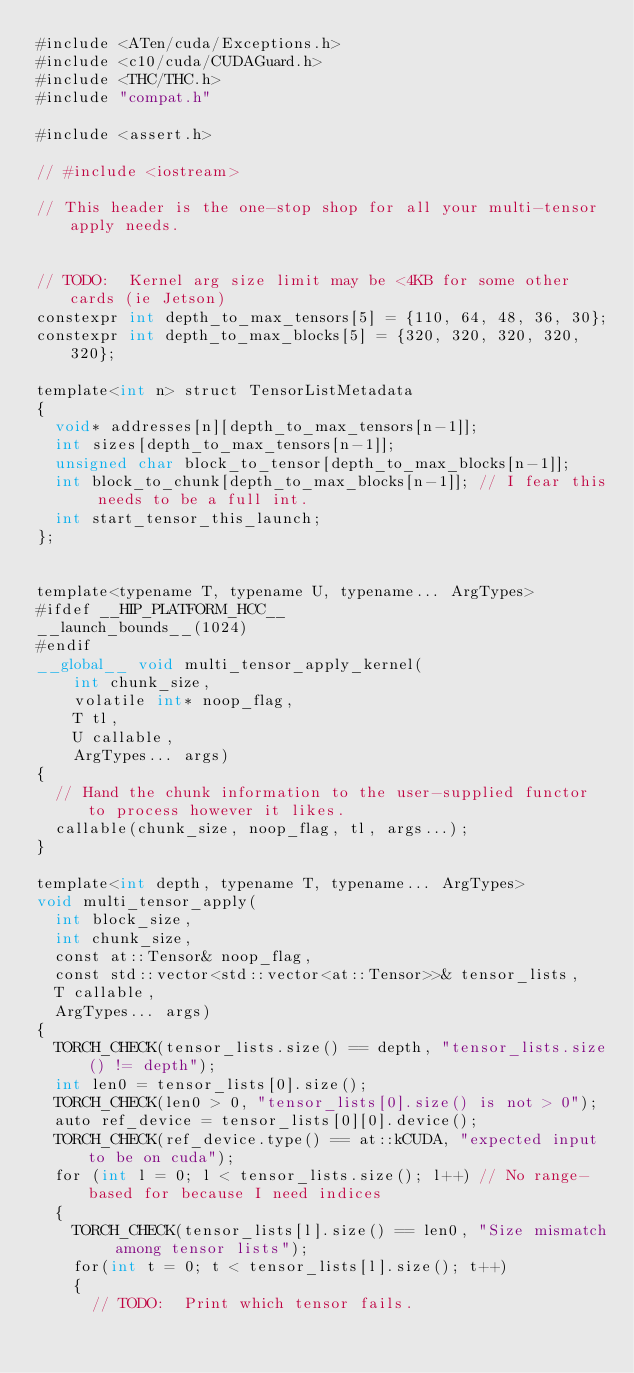Convert code to text. <code><loc_0><loc_0><loc_500><loc_500><_Cuda_>#include <ATen/cuda/Exceptions.h>
#include <c10/cuda/CUDAGuard.h>
#include <THC/THC.h>
#include "compat.h"

#include <assert.h>

// #include <iostream>

// This header is the one-stop shop for all your multi-tensor apply needs.


// TODO:  Kernel arg size limit may be <4KB for some other cards (ie Jetson)
constexpr int depth_to_max_tensors[5] = {110, 64, 48, 36, 30};
constexpr int depth_to_max_blocks[5] = {320, 320, 320, 320, 320};

template<int n> struct TensorListMetadata
{
  void* addresses[n][depth_to_max_tensors[n-1]];
  int sizes[depth_to_max_tensors[n-1]];
  unsigned char block_to_tensor[depth_to_max_blocks[n-1]];
  int block_to_chunk[depth_to_max_blocks[n-1]]; // I fear this needs to be a full int.
  int start_tensor_this_launch;
};


template<typename T, typename U, typename... ArgTypes>
#ifdef __HIP_PLATFORM_HCC__
__launch_bounds__(1024)
#endif
__global__ void multi_tensor_apply_kernel(
    int chunk_size,
    volatile int* noop_flag,
    T tl,
    U callable,
    ArgTypes... args)
{
  // Hand the chunk information to the user-supplied functor to process however it likes.
  callable(chunk_size, noop_flag, tl, args...);
}

template<int depth, typename T, typename... ArgTypes>
void multi_tensor_apply(
  int block_size,
  int chunk_size,
  const at::Tensor& noop_flag,
  const std::vector<std::vector<at::Tensor>>& tensor_lists,
  T callable,
  ArgTypes... args)
{
  TORCH_CHECK(tensor_lists.size() == depth, "tensor_lists.size() != depth");
  int len0 = tensor_lists[0].size();
  TORCH_CHECK(len0 > 0, "tensor_lists[0].size() is not > 0");
  auto ref_device = tensor_lists[0][0].device();
  TORCH_CHECK(ref_device.type() == at::kCUDA, "expected input to be on cuda");
  for (int l = 0; l < tensor_lists.size(); l++) // No range-based for because I need indices
  {
    TORCH_CHECK(tensor_lists[l].size() == len0, "Size mismatch among tensor lists");
    for(int t = 0; t < tensor_lists[l].size(); t++)
    {
      // TODO:  Print which tensor fails.</code> 